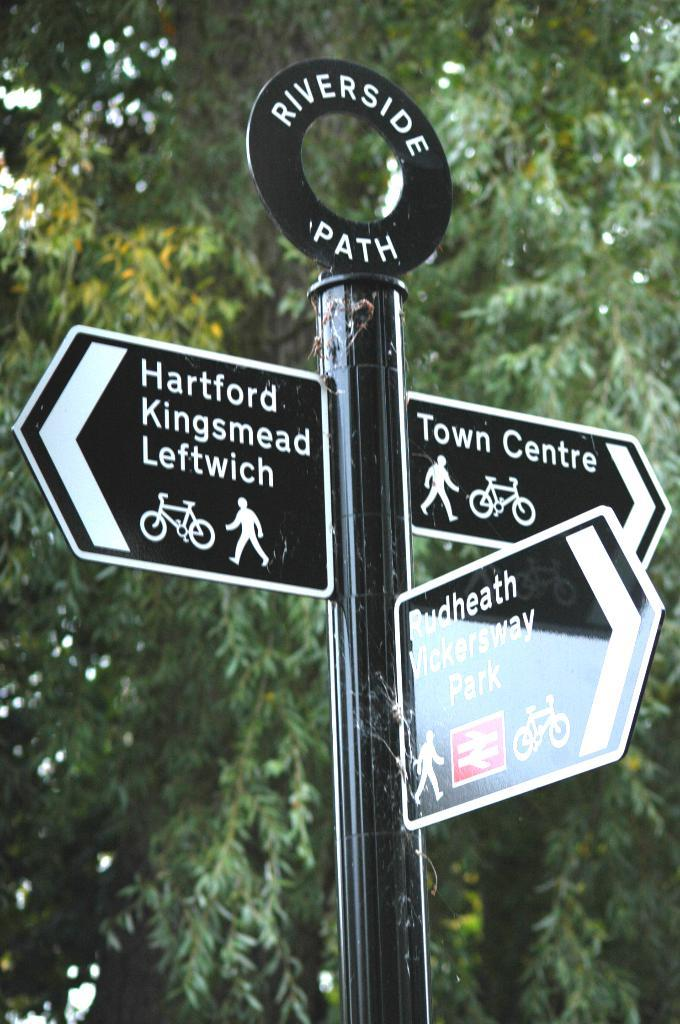What is the main object in the image? There is a black color pole in the image. What is attached to the pole? There are three boards attached to the pole. What can be seen on the boards? Something is written on the boards. What can be seen in the background of the image? There are many trees visible in the background of the image. What type of soup is being served in the image? There is no soup present in the image; it features a black color pole with boards attached to it. Who is the writer of the text on the boards? The facts provided do not give any information about the writer of the text on the boards. 